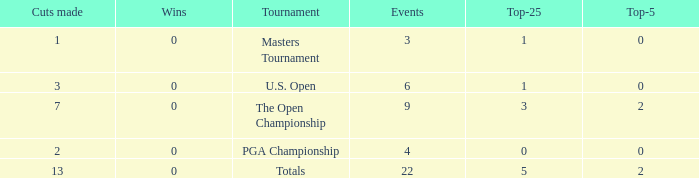What is the total number of wins for events with under 2 top-5s, under 5 top-25s, and more than 4 events played? 1.0. 